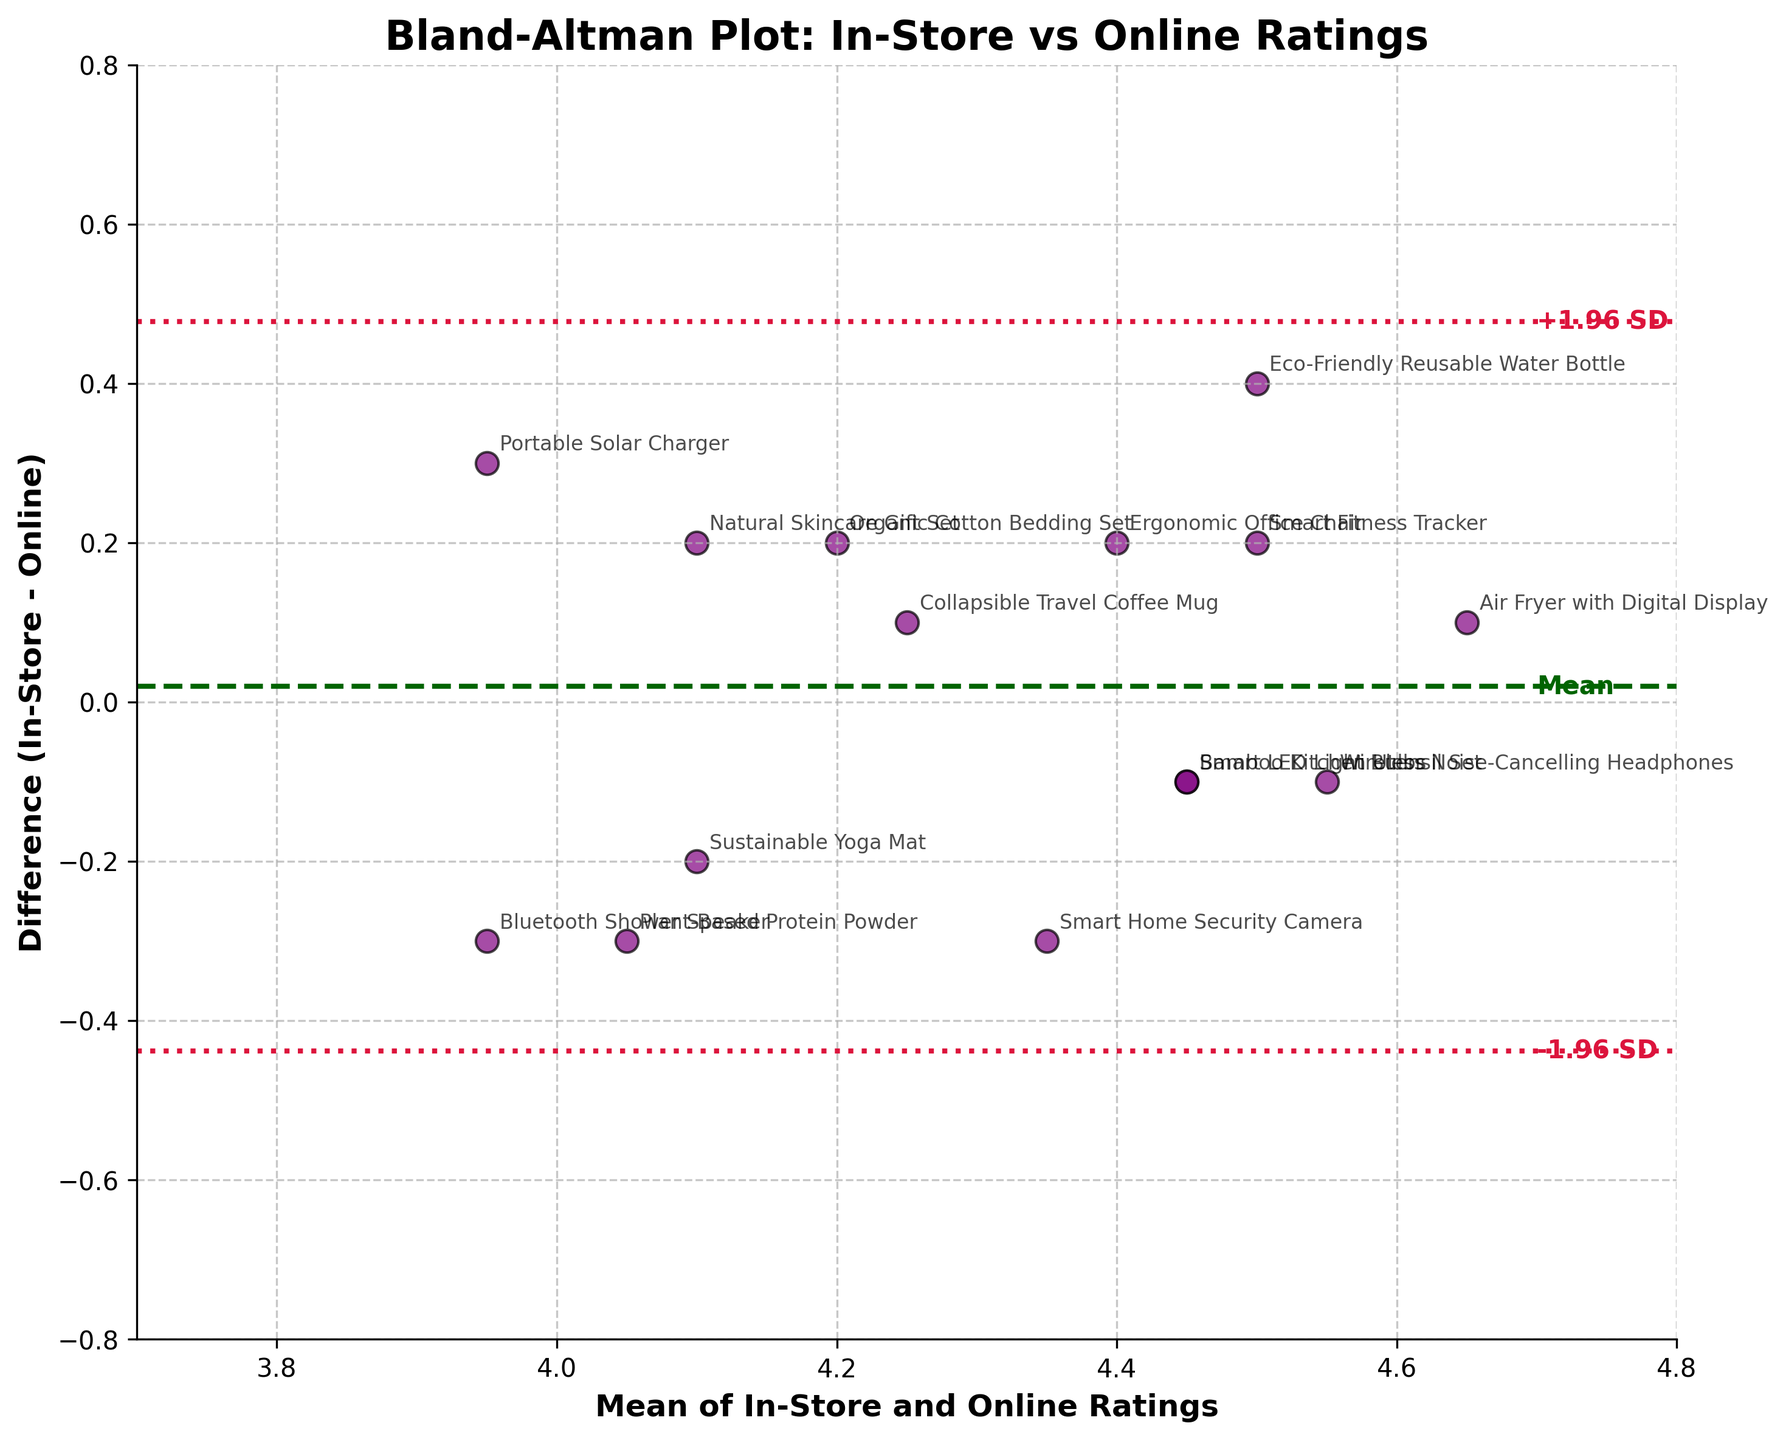How many products' satisfaction ratings are plotted? Count the number of data points represented by scatter points on the plot. Each point corresponds to a product.
Answer: 15 What is the title of the plot? Read the title text located at the top of the plot.
Answer: Bland-Altman Plot: In-Store vs Online Ratings Which product has the largest positive difference in ratings? Identify the scatter point with the highest y-value. Then, check the annotation next to it to determine which product it represents.
Answer: Eco-Friendly Reusable Water Bottle How is the mean difference of ratings between In-Store and Online represented on the plot? Look for a horizontal line that runs across the plot. This line is labeled 'Mean' and typically distinguishes the overall mean difference.
Answer: By a dashed dark green line What do the dotted crimson lines represent? These lines represent the limits of agreement, placed 1.96 standard deviations above and below the mean difference. They are labeled as "+1.96 SD" and "-1.96 SD."
Answer: Limits of agreement Is there a trend in how In-Store and Online ratings differ as the mean rating increases? Observe any patterns in the scatter points as you move from left to right on the horizontal axis, which represents the mean ratings.
Answer: No clear trend What is the mean In-Store and Online rating for the Smart Home Security Camera? Locate the data point labeled "Smart Home Security Camera," then find its position on the x-axis which represents the mean rating. The product's mean rating is calculated as (4.2 + 4.5) / 2.
Answer: 4.35 Which product has a more negative in-store rating compared to its online rating? Identify the scatter points below the horizontal zero line, then look at the annotations to find the products represented.
Answer: Portable Solar Charger What is the span of the x-axis and y-axis in the plot? Count the range from the minimum to the maximum points on both the x-axis and y-axis. The x-axis ranges approximately from 3.7 to 4.8, and the y-axis ranges approximately from -0.8 to 0.8.
Answer: x-axis: 3.7 to 4.8, y-axis: -0.8 to 0.8 Which product shows almost no difference between its in-store and online ratings? Identify the scatter points that lie closest to the horizontal zero line, then check the product annotation next to it.
Answer: Wireless Noise-Cancelling Headphones 